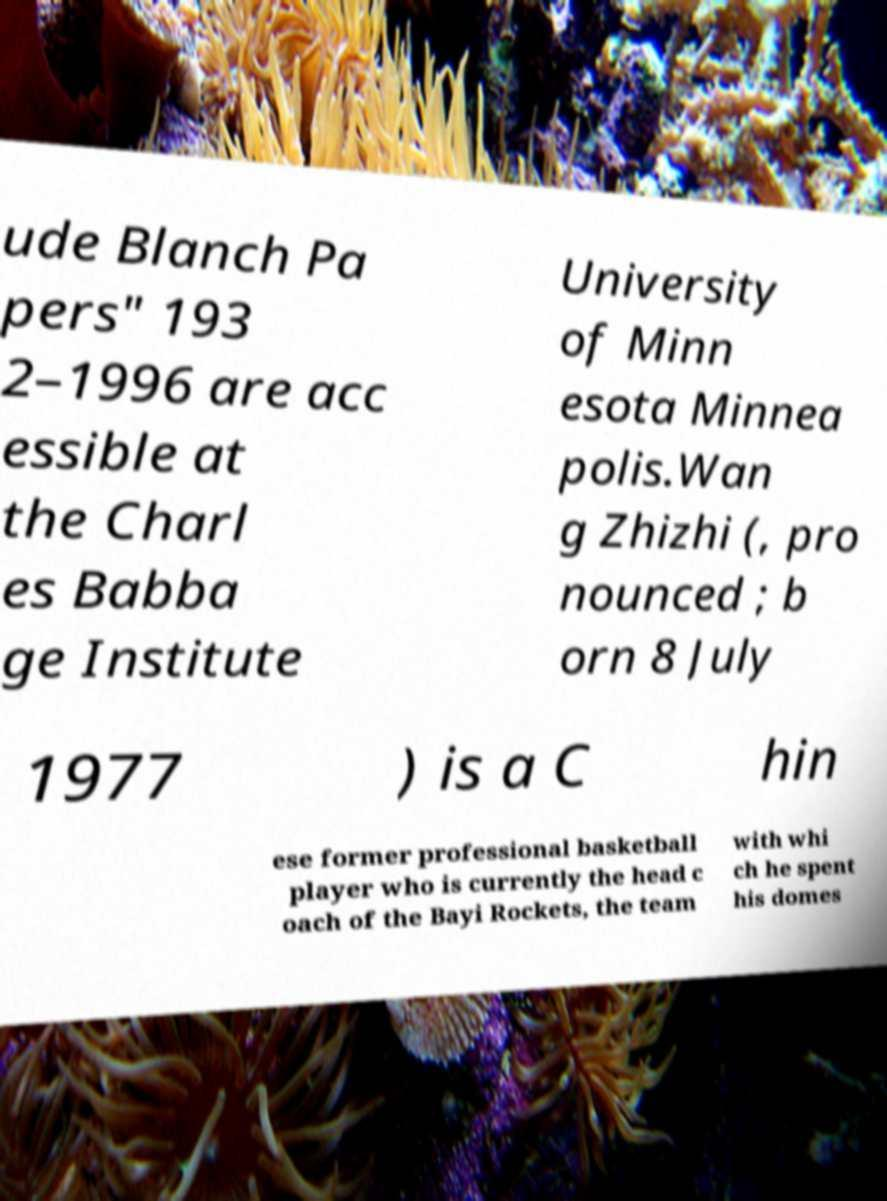Please identify and transcribe the text found in this image. ude Blanch Pa pers" 193 2–1996 are acc essible at the Charl es Babba ge Institute University of Minn esota Minnea polis.Wan g Zhizhi (, pro nounced ; b orn 8 July 1977 ) is a C hin ese former professional basketball player who is currently the head c oach of the Bayi Rockets, the team with whi ch he spent his domes 